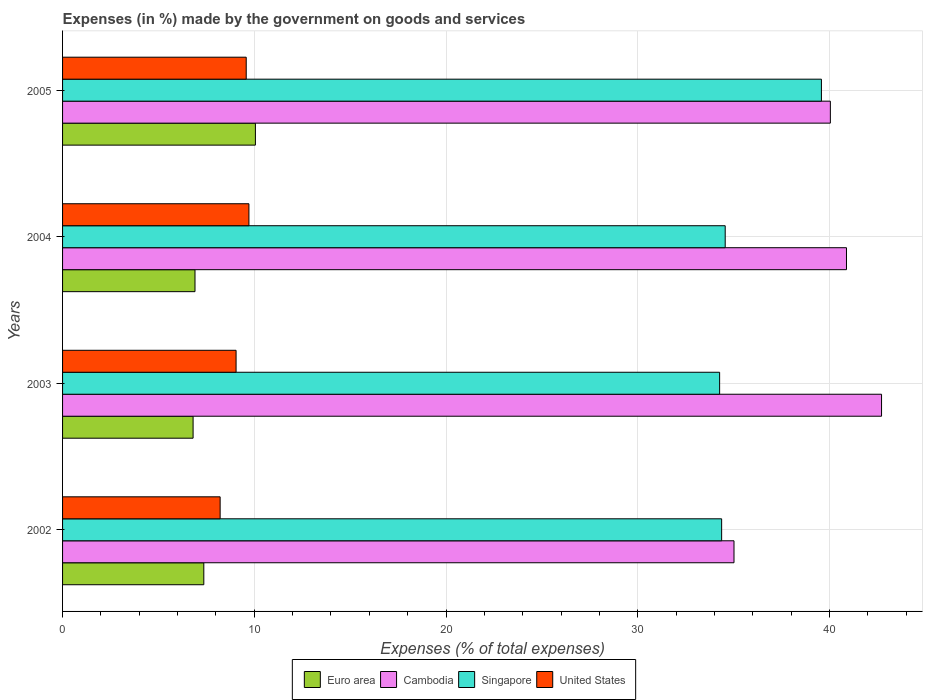Are the number of bars per tick equal to the number of legend labels?
Offer a very short reply. Yes. What is the label of the 4th group of bars from the top?
Make the answer very short. 2002. What is the percentage of expenses made by the government on goods and services in Cambodia in 2002?
Provide a succinct answer. 35.02. Across all years, what is the maximum percentage of expenses made by the government on goods and services in Cambodia?
Ensure brevity in your answer.  42.72. Across all years, what is the minimum percentage of expenses made by the government on goods and services in United States?
Keep it short and to the point. 8.22. In which year was the percentage of expenses made by the government on goods and services in Euro area maximum?
Keep it short and to the point. 2005. What is the total percentage of expenses made by the government on goods and services in Singapore in the graph?
Ensure brevity in your answer.  142.8. What is the difference between the percentage of expenses made by the government on goods and services in Singapore in 2003 and that in 2004?
Provide a succinct answer. -0.29. What is the difference between the percentage of expenses made by the government on goods and services in Singapore in 2004 and the percentage of expenses made by the government on goods and services in Cambodia in 2003?
Make the answer very short. -8.15. What is the average percentage of expenses made by the government on goods and services in Cambodia per year?
Provide a short and direct response. 39.67. In the year 2004, what is the difference between the percentage of expenses made by the government on goods and services in United States and percentage of expenses made by the government on goods and services in Cambodia?
Your response must be concise. -31.17. What is the ratio of the percentage of expenses made by the government on goods and services in United States in 2003 to that in 2004?
Ensure brevity in your answer.  0.93. Is the percentage of expenses made by the government on goods and services in Singapore in 2004 less than that in 2005?
Your response must be concise. Yes. Is the difference between the percentage of expenses made by the government on goods and services in United States in 2003 and 2005 greater than the difference between the percentage of expenses made by the government on goods and services in Cambodia in 2003 and 2005?
Provide a succinct answer. No. What is the difference between the highest and the second highest percentage of expenses made by the government on goods and services in United States?
Provide a short and direct response. 0.14. What is the difference between the highest and the lowest percentage of expenses made by the government on goods and services in Singapore?
Offer a terse response. 5.31. Is the sum of the percentage of expenses made by the government on goods and services in United States in 2003 and 2005 greater than the maximum percentage of expenses made by the government on goods and services in Cambodia across all years?
Your answer should be very brief. No. What does the 1st bar from the bottom in 2004 represents?
Make the answer very short. Euro area. Is it the case that in every year, the sum of the percentage of expenses made by the government on goods and services in Singapore and percentage of expenses made by the government on goods and services in United States is greater than the percentage of expenses made by the government on goods and services in Euro area?
Ensure brevity in your answer.  Yes. How many years are there in the graph?
Your answer should be compact. 4. Does the graph contain grids?
Keep it short and to the point. Yes. How are the legend labels stacked?
Your answer should be compact. Horizontal. What is the title of the graph?
Offer a very short reply. Expenses (in %) made by the government on goods and services. Does "Costa Rica" appear as one of the legend labels in the graph?
Offer a terse response. No. What is the label or title of the X-axis?
Provide a short and direct response. Expenses (% of total expenses). What is the label or title of the Y-axis?
Make the answer very short. Years. What is the Expenses (% of total expenses) in Euro area in 2002?
Keep it short and to the point. 7.37. What is the Expenses (% of total expenses) of Cambodia in 2002?
Your response must be concise. 35.02. What is the Expenses (% of total expenses) in Singapore in 2002?
Provide a short and direct response. 34.38. What is the Expenses (% of total expenses) of United States in 2002?
Your answer should be very brief. 8.22. What is the Expenses (% of total expenses) in Euro area in 2003?
Provide a succinct answer. 6.81. What is the Expenses (% of total expenses) of Cambodia in 2003?
Make the answer very short. 42.72. What is the Expenses (% of total expenses) of Singapore in 2003?
Give a very brief answer. 34.27. What is the Expenses (% of total expenses) in United States in 2003?
Your answer should be compact. 9.05. What is the Expenses (% of total expenses) of Euro area in 2004?
Provide a short and direct response. 6.91. What is the Expenses (% of total expenses) of Cambodia in 2004?
Your answer should be very brief. 40.89. What is the Expenses (% of total expenses) of Singapore in 2004?
Offer a very short reply. 34.56. What is the Expenses (% of total expenses) of United States in 2004?
Offer a very short reply. 9.72. What is the Expenses (% of total expenses) of Euro area in 2005?
Make the answer very short. 10.06. What is the Expenses (% of total expenses) in Cambodia in 2005?
Your answer should be very brief. 40.05. What is the Expenses (% of total expenses) of Singapore in 2005?
Offer a very short reply. 39.58. What is the Expenses (% of total expenses) in United States in 2005?
Offer a very short reply. 9.58. Across all years, what is the maximum Expenses (% of total expenses) of Euro area?
Offer a terse response. 10.06. Across all years, what is the maximum Expenses (% of total expenses) of Cambodia?
Keep it short and to the point. 42.72. Across all years, what is the maximum Expenses (% of total expenses) of Singapore?
Your answer should be compact. 39.58. Across all years, what is the maximum Expenses (% of total expenses) of United States?
Make the answer very short. 9.72. Across all years, what is the minimum Expenses (% of total expenses) of Euro area?
Keep it short and to the point. 6.81. Across all years, what is the minimum Expenses (% of total expenses) in Cambodia?
Offer a very short reply. 35.02. Across all years, what is the minimum Expenses (% of total expenses) in Singapore?
Your answer should be very brief. 34.27. Across all years, what is the minimum Expenses (% of total expenses) in United States?
Offer a very short reply. 8.22. What is the total Expenses (% of total expenses) of Euro area in the graph?
Give a very brief answer. 31.14. What is the total Expenses (% of total expenses) in Cambodia in the graph?
Keep it short and to the point. 158.68. What is the total Expenses (% of total expenses) of Singapore in the graph?
Provide a succinct answer. 142.8. What is the total Expenses (% of total expenses) in United States in the graph?
Offer a terse response. 36.57. What is the difference between the Expenses (% of total expenses) of Euro area in 2002 and that in 2003?
Make the answer very short. 0.56. What is the difference between the Expenses (% of total expenses) of Cambodia in 2002 and that in 2003?
Your answer should be very brief. -7.7. What is the difference between the Expenses (% of total expenses) in Singapore in 2002 and that in 2003?
Provide a succinct answer. 0.1. What is the difference between the Expenses (% of total expenses) of United States in 2002 and that in 2003?
Your answer should be very brief. -0.83. What is the difference between the Expenses (% of total expenses) in Euro area in 2002 and that in 2004?
Make the answer very short. 0.46. What is the difference between the Expenses (% of total expenses) in Cambodia in 2002 and that in 2004?
Keep it short and to the point. -5.87. What is the difference between the Expenses (% of total expenses) in Singapore in 2002 and that in 2004?
Your answer should be compact. -0.19. What is the difference between the Expenses (% of total expenses) in United States in 2002 and that in 2004?
Your answer should be very brief. -1.5. What is the difference between the Expenses (% of total expenses) of Euro area in 2002 and that in 2005?
Keep it short and to the point. -2.69. What is the difference between the Expenses (% of total expenses) in Cambodia in 2002 and that in 2005?
Offer a very short reply. -5.03. What is the difference between the Expenses (% of total expenses) in Singapore in 2002 and that in 2005?
Your response must be concise. -5.2. What is the difference between the Expenses (% of total expenses) of United States in 2002 and that in 2005?
Offer a very short reply. -1.36. What is the difference between the Expenses (% of total expenses) in Euro area in 2003 and that in 2004?
Offer a terse response. -0.1. What is the difference between the Expenses (% of total expenses) in Cambodia in 2003 and that in 2004?
Your answer should be very brief. 1.83. What is the difference between the Expenses (% of total expenses) of Singapore in 2003 and that in 2004?
Offer a terse response. -0.29. What is the difference between the Expenses (% of total expenses) of United States in 2003 and that in 2004?
Make the answer very short. -0.67. What is the difference between the Expenses (% of total expenses) of Euro area in 2003 and that in 2005?
Keep it short and to the point. -3.25. What is the difference between the Expenses (% of total expenses) in Cambodia in 2003 and that in 2005?
Make the answer very short. 2.67. What is the difference between the Expenses (% of total expenses) of Singapore in 2003 and that in 2005?
Provide a succinct answer. -5.31. What is the difference between the Expenses (% of total expenses) in United States in 2003 and that in 2005?
Your answer should be compact. -0.53. What is the difference between the Expenses (% of total expenses) in Euro area in 2004 and that in 2005?
Your answer should be very brief. -3.15. What is the difference between the Expenses (% of total expenses) in Cambodia in 2004 and that in 2005?
Provide a succinct answer. 0.84. What is the difference between the Expenses (% of total expenses) of Singapore in 2004 and that in 2005?
Give a very brief answer. -5.02. What is the difference between the Expenses (% of total expenses) of United States in 2004 and that in 2005?
Your answer should be compact. 0.14. What is the difference between the Expenses (% of total expenses) of Euro area in 2002 and the Expenses (% of total expenses) of Cambodia in 2003?
Provide a succinct answer. -35.35. What is the difference between the Expenses (% of total expenses) of Euro area in 2002 and the Expenses (% of total expenses) of Singapore in 2003?
Give a very brief answer. -26.91. What is the difference between the Expenses (% of total expenses) of Euro area in 2002 and the Expenses (% of total expenses) of United States in 2003?
Your response must be concise. -1.68. What is the difference between the Expenses (% of total expenses) in Cambodia in 2002 and the Expenses (% of total expenses) in Singapore in 2003?
Keep it short and to the point. 0.75. What is the difference between the Expenses (% of total expenses) of Cambodia in 2002 and the Expenses (% of total expenses) of United States in 2003?
Offer a terse response. 25.97. What is the difference between the Expenses (% of total expenses) of Singapore in 2002 and the Expenses (% of total expenses) of United States in 2003?
Keep it short and to the point. 25.33. What is the difference between the Expenses (% of total expenses) of Euro area in 2002 and the Expenses (% of total expenses) of Cambodia in 2004?
Your answer should be compact. -33.52. What is the difference between the Expenses (% of total expenses) in Euro area in 2002 and the Expenses (% of total expenses) in Singapore in 2004?
Offer a terse response. -27.2. What is the difference between the Expenses (% of total expenses) in Euro area in 2002 and the Expenses (% of total expenses) in United States in 2004?
Offer a very short reply. -2.35. What is the difference between the Expenses (% of total expenses) of Cambodia in 2002 and the Expenses (% of total expenses) of Singapore in 2004?
Give a very brief answer. 0.46. What is the difference between the Expenses (% of total expenses) in Cambodia in 2002 and the Expenses (% of total expenses) in United States in 2004?
Give a very brief answer. 25.3. What is the difference between the Expenses (% of total expenses) in Singapore in 2002 and the Expenses (% of total expenses) in United States in 2004?
Provide a succinct answer. 24.66. What is the difference between the Expenses (% of total expenses) in Euro area in 2002 and the Expenses (% of total expenses) in Cambodia in 2005?
Provide a succinct answer. -32.68. What is the difference between the Expenses (% of total expenses) in Euro area in 2002 and the Expenses (% of total expenses) in Singapore in 2005?
Your response must be concise. -32.21. What is the difference between the Expenses (% of total expenses) in Euro area in 2002 and the Expenses (% of total expenses) in United States in 2005?
Keep it short and to the point. -2.21. What is the difference between the Expenses (% of total expenses) in Cambodia in 2002 and the Expenses (% of total expenses) in Singapore in 2005?
Keep it short and to the point. -4.56. What is the difference between the Expenses (% of total expenses) in Cambodia in 2002 and the Expenses (% of total expenses) in United States in 2005?
Give a very brief answer. 25.44. What is the difference between the Expenses (% of total expenses) of Singapore in 2002 and the Expenses (% of total expenses) of United States in 2005?
Ensure brevity in your answer.  24.8. What is the difference between the Expenses (% of total expenses) in Euro area in 2003 and the Expenses (% of total expenses) in Cambodia in 2004?
Offer a terse response. -34.08. What is the difference between the Expenses (% of total expenses) of Euro area in 2003 and the Expenses (% of total expenses) of Singapore in 2004?
Keep it short and to the point. -27.76. What is the difference between the Expenses (% of total expenses) in Euro area in 2003 and the Expenses (% of total expenses) in United States in 2004?
Keep it short and to the point. -2.91. What is the difference between the Expenses (% of total expenses) in Cambodia in 2003 and the Expenses (% of total expenses) in Singapore in 2004?
Your answer should be compact. 8.15. What is the difference between the Expenses (% of total expenses) of Cambodia in 2003 and the Expenses (% of total expenses) of United States in 2004?
Offer a terse response. 33. What is the difference between the Expenses (% of total expenses) of Singapore in 2003 and the Expenses (% of total expenses) of United States in 2004?
Ensure brevity in your answer.  24.55. What is the difference between the Expenses (% of total expenses) in Euro area in 2003 and the Expenses (% of total expenses) in Cambodia in 2005?
Your response must be concise. -33.24. What is the difference between the Expenses (% of total expenses) of Euro area in 2003 and the Expenses (% of total expenses) of Singapore in 2005?
Give a very brief answer. -32.77. What is the difference between the Expenses (% of total expenses) in Euro area in 2003 and the Expenses (% of total expenses) in United States in 2005?
Ensure brevity in your answer.  -2.77. What is the difference between the Expenses (% of total expenses) in Cambodia in 2003 and the Expenses (% of total expenses) in Singapore in 2005?
Offer a terse response. 3.14. What is the difference between the Expenses (% of total expenses) in Cambodia in 2003 and the Expenses (% of total expenses) in United States in 2005?
Make the answer very short. 33.14. What is the difference between the Expenses (% of total expenses) of Singapore in 2003 and the Expenses (% of total expenses) of United States in 2005?
Your answer should be compact. 24.69. What is the difference between the Expenses (% of total expenses) of Euro area in 2004 and the Expenses (% of total expenses) of Cambodia in 2005?
Offer a very short reply. -33.14. What is the difference between the Expenses (% of total expenses) in Euro area in 2004 and the Expenses (% of total expenses) in Singapore in 2005?
Ensure brevity in your answer.  -32.67. What is the difference between the Expenses (% of total expenses) in Euro area in 2004 and the Expenses (% of total expenses) in United States in 2005?
Ensure brevity in your answer.  -2.67. What is the difference between the Expenses (% of total expenses) of Cambodia in 2004 and the Expenses (% of total expenses) of Singapore in 2005?
Offer a terse response. 1.31. What is the difference between the Expenses (% of total expenses) in Cambodia in 2004 and the Expenses (% of total expenses) in United States in 2005?
Make the answer very short. 31.31. What is the difference between the Expenses (% of total expenses) of Singapore in 2004 and the Expenses (% of total expenses) of United States in 2005?
Offer a very short reply. 24.98. What is the average Expenses (% of total expenses) of Euro area per year?
Make the answer very short. 7.79. What is the average Expenses (% of total expenses) of Cambodia per year?
Ensure brevity in your answer.  39.67. What is the average Expenses (% of total expenses) of Singapore per year?
Offer a terse response. 35.7. What is the average Expenses (% of total expenses) of United States per year?
Offer a very short reply. 9.14. In the year 2002, what is the difference between the Expenses (% of total expenses) of Euro area and Expenses (% of total expenses) of Cambodia?
Keep it short and to the point. -27.65. In the year 2002, what is the difference between the Expenses (% of total expenses) of Euro area and Expenses (% of total expenses) of Singapore?
Your answer should be compact. -27.01. In the year 2002, what is the difference between the Expenses (% of total expenses) of Euro area and Expenses (% of total expenses) of United States?
Ensure brevity in your answer.  -0.85. In the year 2002, what is the difference between the Expenses (% of total expenses) in Cambodia and Expenses (% of total expenses) in Singapore?
Your response must be concise. 0.64. In the year 2002, what is the difference between the Expenses (% of total expenses) of Cambodia and Expenses (% of total expenses) of United States?
Keep it short and to the point. 26.8. In the year 2002, what is the difference between the Expenses (% of total expenses) of Singapore and Expenses (% of total expenses) of United States?
Your answer should be very brief. 26.16. In the year 2003, what is the difference between the Expenses (% of total expenses) in Euro area and Expenses (% of total expenses) in Cambodia?
Ensure brevity in your answer.  -35.91. In the year 2003, what is the difference between the Expenses (% of total expenses) in Euro area and Expenses (% of total expenses) in Singapore?
Provide a succinct answer. -27.46. In the year 2003, what is the difference between the Expenses (% of total expenses) of Euro area and Expenses (% of total expenses) of United States?
Provide a succinct answer. -2.24. In the year 2003, what is the difference between the Expenses (% of total expenses) of Cambodia and Expenses (% of total expenses) of Singapore?
Your answer should be very brief. 8.45. In the year 2003, what is the difference between the Expenses (% of total expenses) of Cambodia and Expenses (% of total expenses) of United States?
Make the answer very short. 33.67. In the year 2003, what is the difference between the Expenses (% of total expenses) of Singapore and Expenses (% of total expenses) of United States?
Make the answer very short. 25.22. In the year 2004, what is the difference between the Expenses (% of total expenses) in Euro area and Expenses (% of total expenses) in Cambodia?
Provide a succinct answer. -33.98. In the year 2004, what is the difference between the Expenses (% of total expenses) of Euro area and Expenses (% of total expenses) of Singapore?
Give a very brief answer. -27.66. In the year 2004, what is the difference between the Expenses (% of total expenses) in Euro area and Expenses (% of total expenses) in United States?
Ensure brevity in your answer.  -2.81. In the year 2004, what is the difference between the Expenses (% of total expenses) of Cambodia and Expenses (% of total expenses) of Singapore?
Make the answer very short. 6.33. In the year 2004, what is the difference between the Expenses (% of total expenses) of Cambodia and Expenses (% of total expenses) of United States?
Offer a very short reply. 31.17. In the year 2004, what is the difference between the Expenses (% of total expenses) of Singapore and Expenses (% of total expenses) of United States?
Your answer should be compact. 24.84. In the year 2005, what is the difference between the Expenses (% of total expenses) in Euro area and Expenses (% of total expenses) in Cambodia?
Offer a very short reply. -29.99. In the year 2005, what is the difference between the Expenses (% of total expenses) of Euro area and Expenses (% of total expenses) of Singapore?
Keep it short and to the point. -29.52. In the year 2005, what is the difference between the Expenses (% of total expenses) of Euro area and Expenses (% of total expenses) of United States?
Make the answer very short. 0.48. In the year 2005, what is the difference between the Expenses (% of total expenses) in Cambodia and Expenses (% of total expenses) in Singapore?
Give a very brief answer. 0.47. In the year 2005, what is the difference between the Expenses (% of total expenses) of Cambodia and Expenses (% of total expenses) of United States?
Keep it short and to the point. 30.47. In the year 2005, what is the difference between the Expenses (% of total expenses) in Singapore and Expenses (% of total expenses) in United States?
Provide a succinct answer. 30. What is the ratio of the Expenses (% of total expenses) in Euro area in 2002 to that in 2003?
Your answer should be compact. 1.08. What is the ratio of the Expenses (% of total expenses) of Cambodia in 2002 to that in 2003?
Ensure brevity in your answer.  0.82. What is the ratio of the Expenses (% of total expenses) of Singapore in 2002 to that in 2003?
Offer a terse response. 1. What is the ratio of the Expenses (% of total expenses) of United States in 2002 to that in 2003?
Provide a succinct answer. 0.91. What is the ratio of the Expenses (% of total expenses) in Euro area in 2002 to that in 2004?
Provide a succinct answer. 1.07. What is the ratio of the Expenses (% of total expenses) of Cambodia in 2002 to that in 2004?
Keep it short and to the point. 0.86. What is the ratio of the Expenses (% of total expenses) of United States in 2002 to that in 2004?
Your answer should be very brief. 0.85. What is the ratio of the Expenses (% of total expenses) in Euro area in 2002 to that in 2005?
Your answer should be compact. 0.73. What is the ratio of the Expenses (% of total expenses) in Cambodia in 2002 to that in 2005?
Keep it short and to the point. 0.87. What is the ratio of the Expenses (% of total expenses) of Singapore in 2002 to that in 2005?
Your response must be concise. 0.87. What is the ratio of the Expenses (% of total expenses) in United States in 2002 to that in 2005?
Offer a terse response. 0.86. What is the ratio of the Expenses (% of total expenses) of Euro area in 2003 to that in 2004?
Make the answer very short. 0.99. What is the ratio of the Expenses (% of total expenses) in Cambodia in 2003 to that in 2004?
Provide a short and direct response. 1.04. What is the ratio of the Expenses (% of total expenses) of United States in 2003 to that in 2004?
Ensure brevity in your answer.  0.93. What is the ratio of the Expenses (% of total expenses) of Euro area in 2003 to that in 2005?
Ensure brevity in your answer.  0.68. What is the ratio of the Expenses (% of total expenses) of Cambodia in 2003 to that in 2005?
Provide a short and direct response. 1.07. What is the ratio of the Expenses (% of total expenses) of Singapore in 2003 to that in 2005?
Give a very brief answer. 0.87. What is the ratio of the Expenses (% of total expenses) of United States in 2003 to that in 2005?
Provide a short and direct response. 0.94. What is the ratio of the Expenses (% of total expenses) in Euro area in 2004 to that in 2005?
Your response must be concise. 0.69. What is the ratio of the Expenses (% of total expenses) in Singapore in 2004 to that in 2005?
Keep it short and to the point. 0.87. What is the ratio of the Expenses (% of total expenses) of United States in 2004 to that in 2005?
Offer a very short reply. 1.01. What is the difference between the highest and the second highest Expenses (% of total expenses) of Euro area?
Your answer should be compact. 2.69. What is the difference between the highest and the second highest Expenses (% of total expenses) in Cambodia?
Keep it short and to the point. 1.83. What is the difference between the highest and the second highest Expenses (% of total expenses) of Singapore?
Offer a terse response. 5.02. What is the difference between the highest and the second highest Expenses (% of total expenses) of United States?
Offer a terse response. 0.14. What is the difference between the highest and the lowest Expenses (% of total expenses) in Euro area?
Provide a short and direct response. 3.25. What is the difference between the highest and the lowest Expenses (% of total expenses) of Cambodia?
Make the answer very short. 7.7. What is the difference between the highest and the lowest Expenses (% of total expenses) of Singapore?
Offer a terse response. 5.31. What is the difference between the highest and the lowest Expenses (% of total expenses) in United States?
Your answer should be very brief. 1.5. 